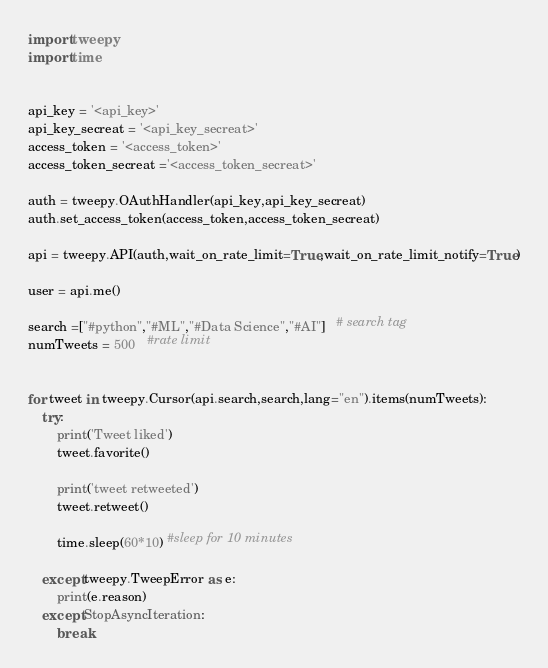Convert code to text. <code><loc_0><loc_0><loc_500><loc_500><_Python_>import tweepy
import time


api_key = '<api_key>'
api_key_secreat = '<api_key_secreat>'
access_token = '<access_token>'
access_token_secreat ='<access_token_secreat>'

auth = tweepy.OAuthHandler(api_key,api_key_secreat)
auth.set_access_token(access_token,access_token_secreat)

api = tweepy.API(auth,wait_on_rate_limit=True,wait_on_rate_limit_notify=True)

user = api.me()

search =["#python","#ML","#Data Science","#AI"]   # search tag
numTweets = 500   #rate limit


for tweet in tweepy.Cursor(api.search,search,lang="en").items(numTweets):
    try:
        print('Tweet liked')
        tweet.favorite()

        print('tweet retweeted')
        tweet.retweet()

        time.sleep(60*10) #sleep for 10 minutes
        
    except tweepy.TweepError as e:
        print(e.reason)
    except StopAsyncIteration:
        break





</code> 